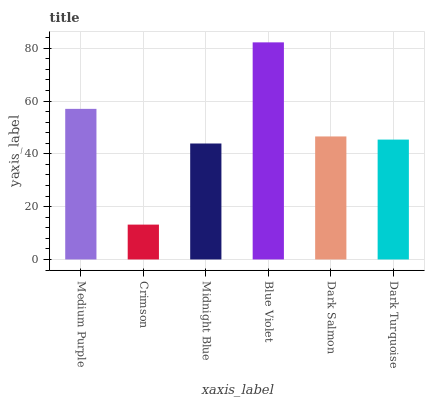Is Midnight Blue the minimum?
Answer yes or no. No. Is Midnight Blue the maximum?
Answer yes or no. No. Is Midnight Blue greater than Crimson?
Answer yes or no. Yes. Is Crimson less than Midnight Blue?
Answer yes or no. Yes. Is Crimson greater than Midnight Blue?
Answer yes or no. No. Is Midnight Blue less than Crimson?
Answer yes or no. No. Is Dark Salmon the high median?
Answer yes or no. Yes. Is Dark Turquoise the low median?
Answer yes or no. Yes. Is Dark Turquoise the high median?
Answer yes or no. No. Is Blue Violet the low median?
Answer yes or no. No. 